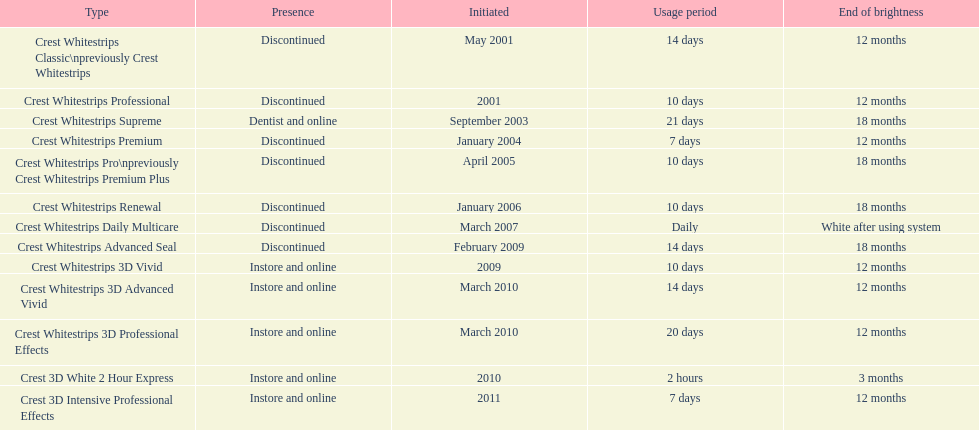What is the number of products that were introduced in 2010? 3. 